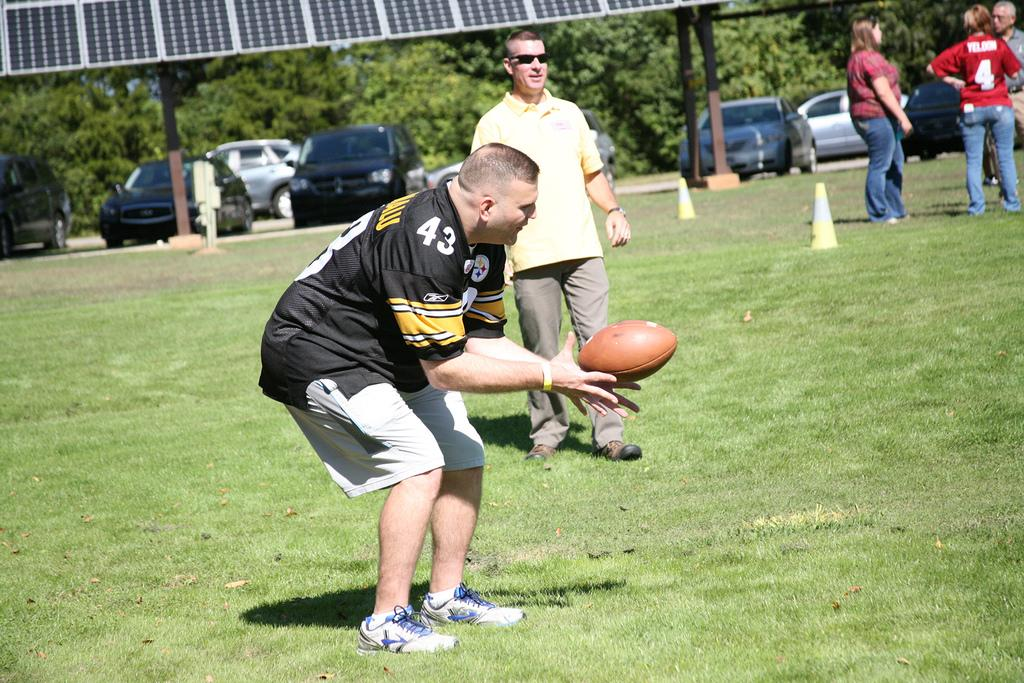Provide a one-sentence caption for the provided image. A man wearing a black jersey with number 43 catches a football. 